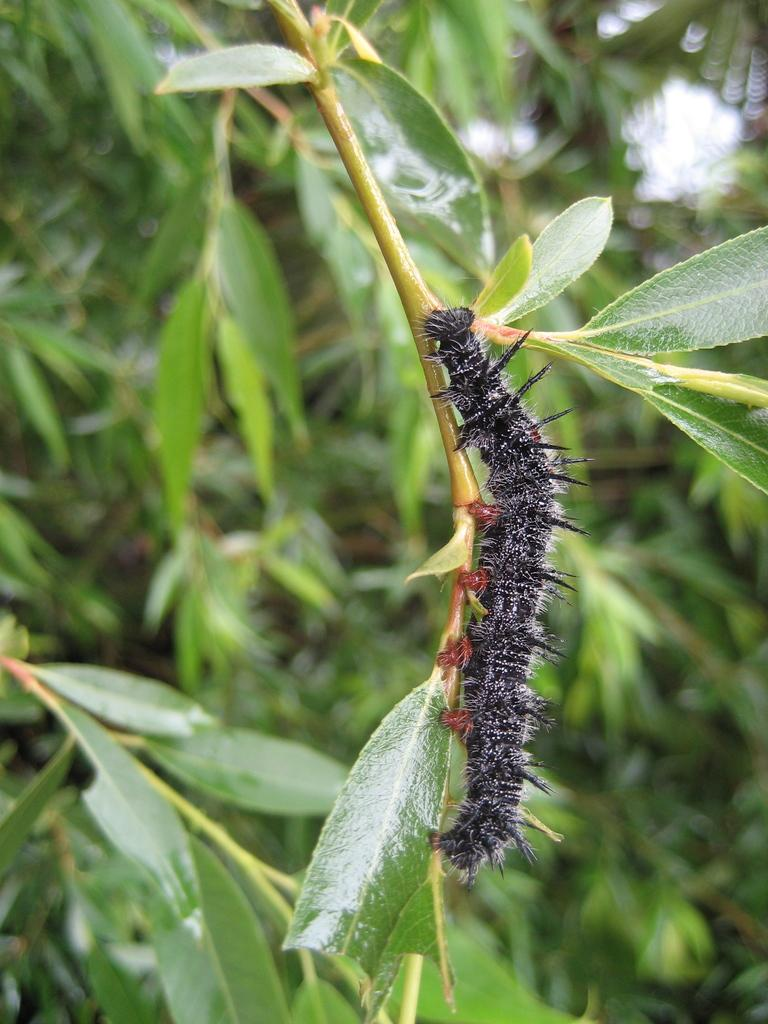What type of creature can be seen in the image? There is an insect in the image. Where is the insect located? The insect is on the stem of a tree. What can be seen in the background of the image? There are green color leaves in the background of the image. How many women are sitting in the library in the image? There is no library or women present in the image; it features an insect on the stem of a tree with green leaves in the background. 